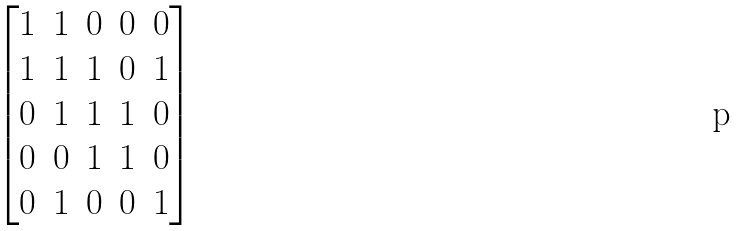Convert formula to latex. <formula><loc_0><loc_0><loc_500><loc_500>\begin{bmatrix} 1 & 1 & 0 & 0 & 0 \\ 1 & 1 & 1 & 0 & 1 \\ 0 & 1 & 1 & 1 & 0 \\ 0 & 0 & 1 & 1 & 0 \\ 0 & 1 & 0 & 0 & 1 \end{bmatrix}</formula> 